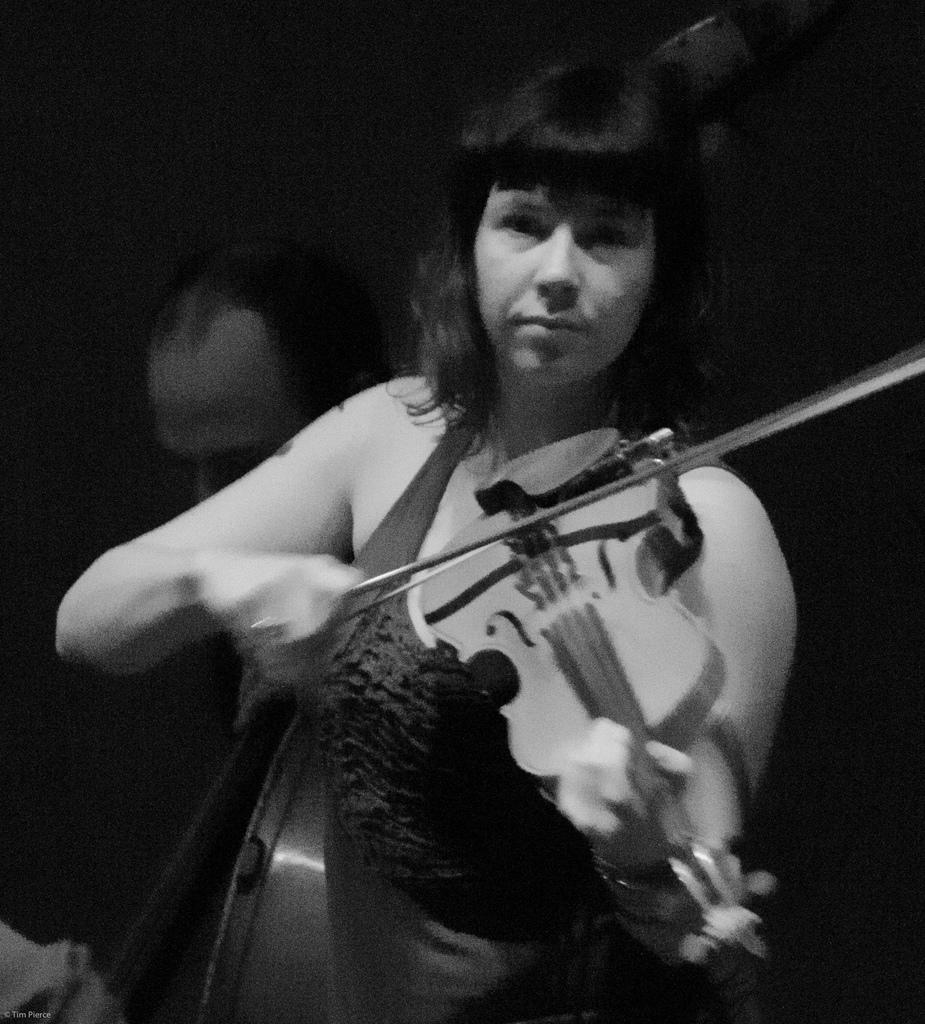What is the color scheme of the image? The image is black and white. What activity is the woman in the image engaged in? The woman is playing a violin in the image. Can you describe the position of the man in the image? There is a man behind the woman in the image. What type of pear is the man holding in the image? There is no pear present in the image; it features a woman playing a violin and a man behind her. How does the friction between the violin and the bow affect the sound produced in the image? The image is black and white and does not provide enough detail to determine the friction between the violin and the bow or its effect on the sound produced. 